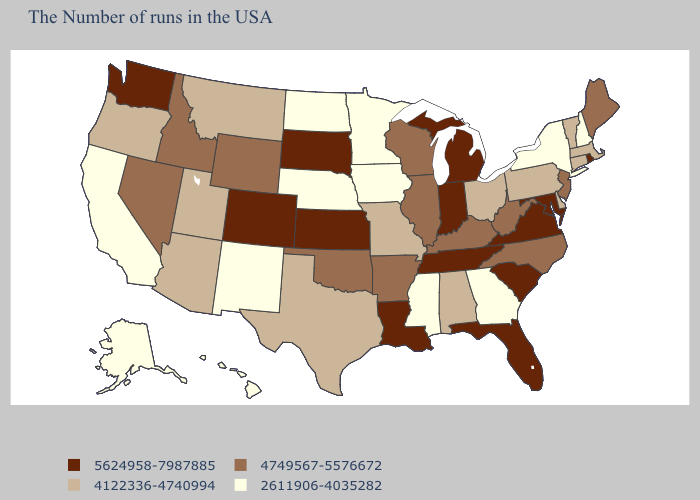Does the map have missing data?
Give a very brief answer. No. Name the states that have a value in the range 5624958-7987885?
Short answer required. Rhode Island, Maryland, Virginia, South Carolina, Florida, Michigan, Indiana, Tennessee, Louisiana, Kansas, South Dakota, Colorado, Washington. Which states have the highest value in the USA?
Give a very brief answer. Rhode Island, Maryland, Virginia, South Carolina, Florida, Michigan, Indiana, Tennessee, Louisiana, Kansas, South Dakota, Colorado, Washington. What is the value of Mississippi?
Concise answer only. 2611906-4035282. Among the states that border Indiana , which have the highest value?
Short answer required. Michigan. Name the states that have a value in the range 4122336-4740994?
Quick response, please. Massachusetts, Vermont, Connecticut, Delaware, Pennsylvania, Ohio, Alabama, Missouri, Texas, Utah, Montana, Arizona, Oregon. What is the value of Mississippi?
Be succinct. 2611906-4035282. Among the states that border Wisconsin , does Minnesota have the lowest value?
Short answer required. Yes. Name the states that have a value in the range 5624958-7987885?
Give a very brief answer. Rhode Island, Maryland, Virginia, South Carolina, Florida, Michigan, Indiana, Tennessee, Louisiana, Kansas, South Dakota, Colorado, Washington. Does North Carolina have the same value as Kentucky?
Quick response, please. Yes. What is the lowest value in the South?
Quick response, please. 2611906-4035282. Which states hav the highest value in the West?
Quick response, please. Colorado, Washington. Does Connecticut have the lowest value in the Northeast?
Keep it brief. No. Name the states that have a value in the range 4122336-4740994?
Be succinct. Massachusetts, Vermont, Connecticut, Delaware, Pennsylvania, Ohio, Alabama, Missouri, Texas, Utah, Montana, Arizona, Oregon. Name the states that have a value in the range 5624958-7987885?
Give a very brief answer. Rhode Island, Maryland, Virginia, South Carolina, Florida, Michigan, Indiana, Tennessee, Louisiana, Kansas, South Dakota, Colorado, Washington. 